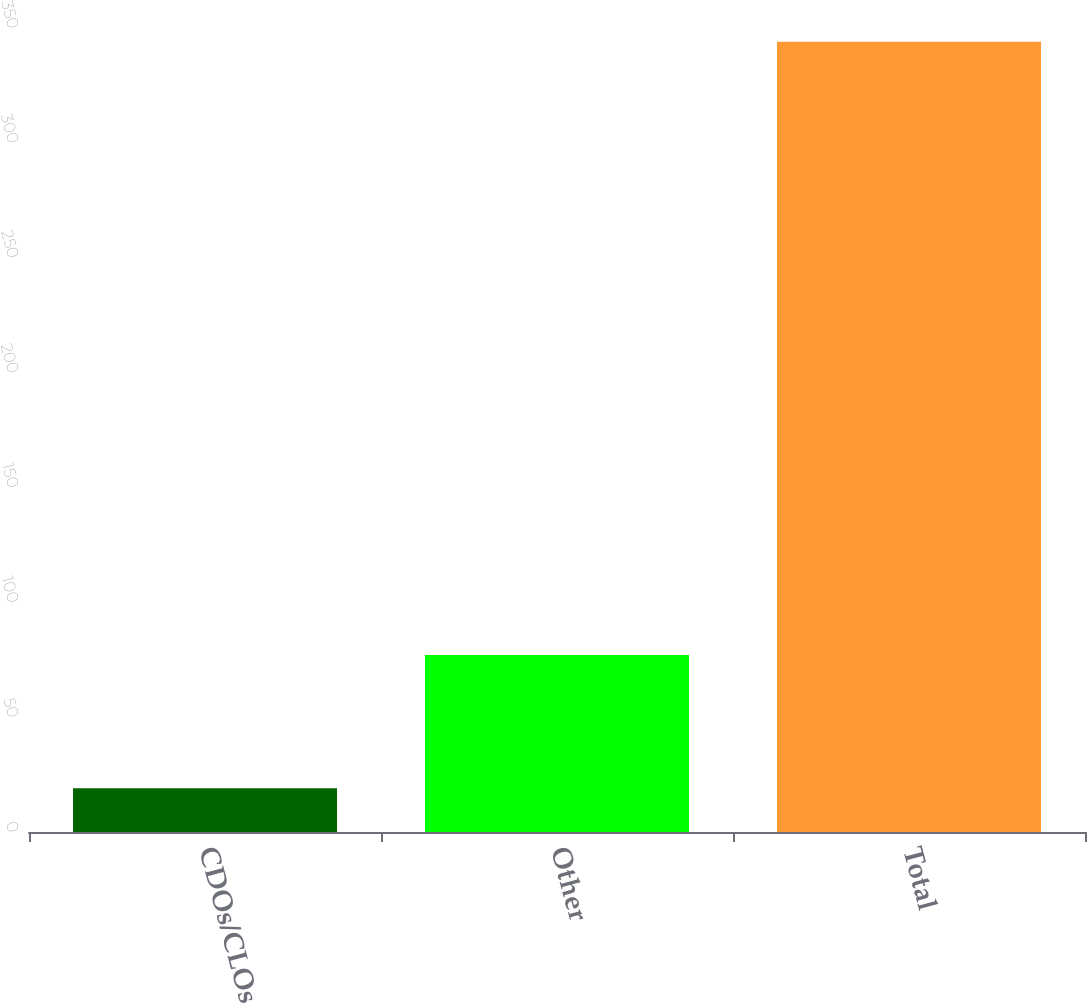Convert chart to OTSL. <chart><loc_0><loc_0><loc_500><loc_500><bar_chart><fcel>CDOs/CLOs<fcel>Other<fcel>Total<nl><fcel>19<fcel>77<fcel>344<nl></chart> 